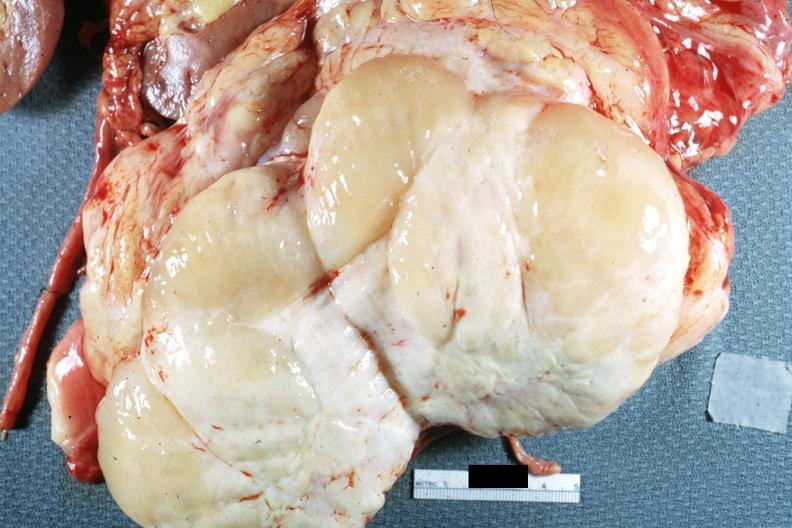what is nodular tumor cut?
Answer the question using a single word or phrase. Surface natural color yellow and white typical gross sarcoma 